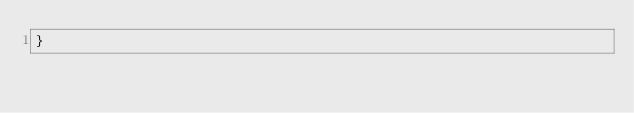Convert code to text. <code><loc_0><loc_0><loc_500><loc_500><_CSS_>}</code> 